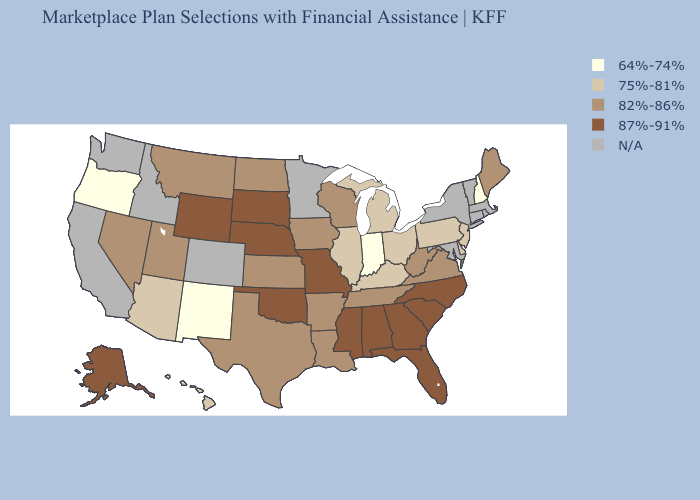Among the states that border Nevada , does Arizona have the lowest value?
Quick response, please. No. Which states hav the highest value in the South?
Keep it brief. Alabama, Florida, Georgia, Mississippi, North Carolina, Oklahoma, South Carolina. What is the value of Michigan?
Be succinct. 75%-81%. What is the value of Vermont?
Keep it brief. N/A. Which states have the lowest value in the USA?
Quick response, please. Indiana, New Hampshire, New Mexico, Oregon. Does Indiana have the lowest value in the MidWest?
Be succinct. Yes. Name the states that have a value in the range 64%-74%?
Short answer required. Indiana, New Hampshire, New Mexico, Oregon. What is the value of Delaware?
Write a very short answer. 75%-81%. How many symbols are there in the legend?
Quick response, please. 5. Among the states that border Oklahoma , which have the highest value?
Be succinct. Missouri. What is the value of Missouri?
Give a very brief answer. 87%-91%. What is the highest value in states that border Nevada?
Keep it brief. 82%-86%. Name the states that have a value in the range 87%-91%?
Quick response, please. Alabama, Alaska, Florida, Georgia, Mississippi, Missouri, Nebraska, North Carolina, Oklahoma, South Carolina, South Dakota, Wyoming. 